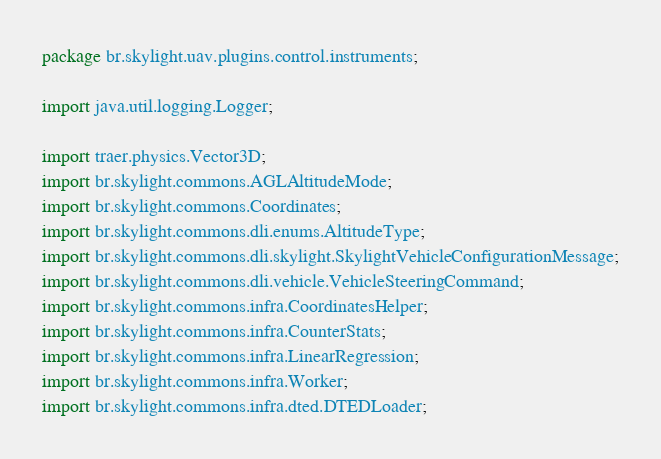<code> <loc_0><loc_0><loc_500><loc_500><_Java_>package br.skylight.uav.plugins.control.instruments;

import java.util.logging.Logger;

import traer.physics.Vector3D;
import br.skylight.commons.AGLAltitudeMode;
import br.skylight.commons.Coordinates;
import br.skylight.commons.dli.enums.AltitudeType;
import br.skylight.commons.dli.skylight.SkylightVehicleConfigurationMessage;
import br.skylight.commons.dli.vehicle.VehicleSteeringCommand;
import br.skylight.commons.infra.CoordinatesHelper;
import br.skylight.commons.infra.CounterStats;
import br.skylight.commons.infra.LinearRegression;
import br.skylight.commons.infra.Worker;
import br.skylight.commons.infra.dted.DTEDLoader;</code> 